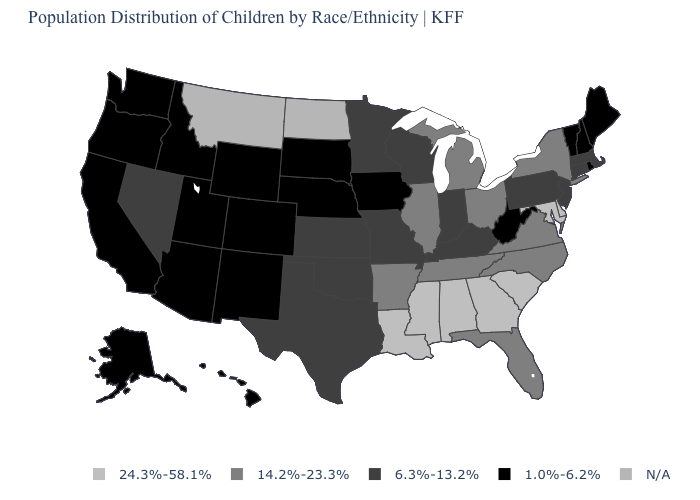Name the states that have a value in the range 24.3%-58.1%?
Concise answer only. Alabama, Delaware, Georgia, Louisiana, Maryland, Mississippi, South Carolina. Name the states that have a value in the range 6.3%-13.2%?
Be succinct. Connecticut, Indiana, Kansas, Kentucky, Massachusetts, Minnesota, Missouri, Nevada, New Jersey, Oklahoma, Pennsylvania, Texas, Wisconsin. What is the value of New Hampshire?
Short answer required. 1.0%-6.2%. What is the value of Tennessee?
Quick response, please. 14.2%-23.3%. What is the highest value in states that border Minnesota?
Keep it brief. 6.3%-13.2%. Name the states that have a value in the range N/A?
Short answer required. Montana, North Dakota. What is the value of Georgia?
Give a very brief answer. 24.3%-58.1%. What is the highest value in states that border Massachusetts?
Concise answer only. 14.2%-23.3%. What is the highest value in states that border Oklahoma?
Concise answer only. 14.2%-23.3%. Name the states that have a value in the range 14.2%-23.3%?
Answer briefly. Arkansas, Florida, Illinois, Michigan, New York, North Carolina, Ohio, Tennessee, Virginia. What is the value of Washington?
Answer briefly. 1.0%-6.2%. Which states have the lowest value in the West?
Concise answer only. Alaska, Arizona, California, Colorado, Hawaii, Idaho, New Mexico, Oregon, Utah, Washington, Wyoming. What is the lowest value in the West?
Be succinct. 1.0%-6.2%. Does the first symbol in the legend represent the smallest category?
Be succinct. No. 